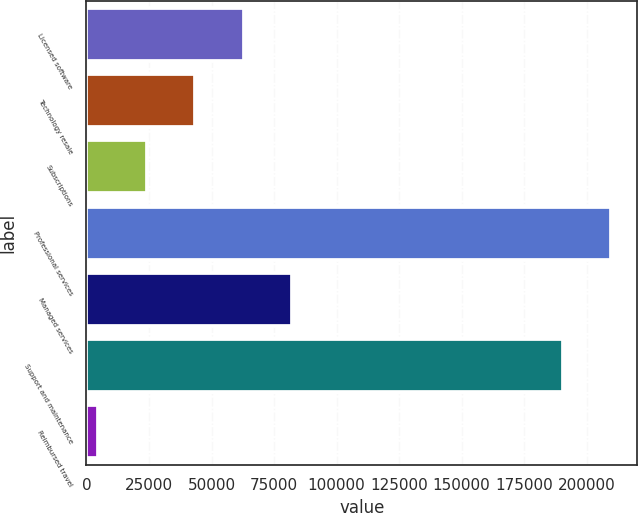<chart> <loc_0><loc_0><loc_500><loc_500><bar_chart><fcel>Licensed software<fcel>Technology resale<fcel>Subscriptions<fcel>Professional services<fcel>Managed services<fcel>Support and maintenance<fcel>Reimbursed travel<nl><fcel>62952.4<fcel>43546.6<fcel>24140.8<fcel>209758<fcel>82358.2<fcel>190352<fcel>4735<nl></chart> 